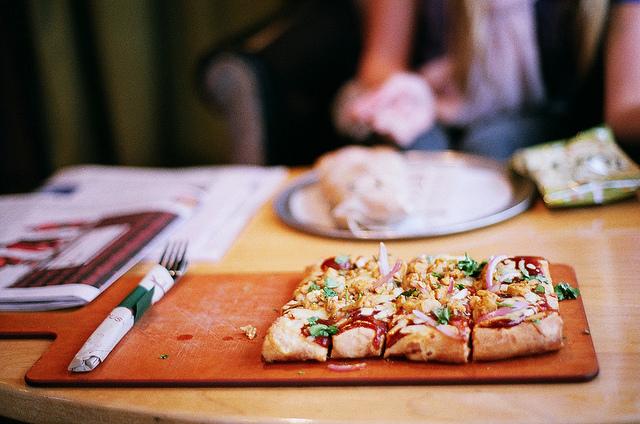What is wrapped around the fork?
Write a very short answer. Napkin. What type of food is this?
Short answer required. Pizza. Why does the platter have a long handle?
Concise answer only. To hold. 